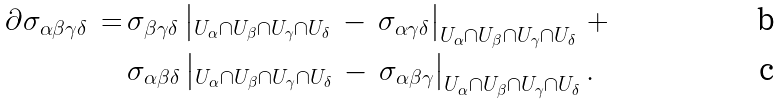<formula> <loc_0><loc_0><loc_500><loc_500>\partial \sigma _ { \alpha \beta \gamma \delta } \, = \, & \sigma _ { \beta \gamma \delta } \left | _ { U _ { \alpha } \cap U _ { \beta } \cap U _ { \gamma } \cap U _ { \delta } } \, - \, \sigma _ { \alpha \gamma \delta } \right | _ { U _ { \alpha } \cap U _ { \beta } \cap U _ { \gamma } \cap U _ { \delta } } \, + \\ & \sigma _ { \alpha \beta \delta } \left | _ { U _ { \alpha } \cap U _ { \beta } \cap U _ { \gamma } \cap U _ { \delta } } \, - \, \sigma _ { \alpha \beta \gamma } \right | _ { U _ { \alpha } \cap U _ { \beta } \cap U _ { \gamma } \cap U _ { \delta } } .</formula> 